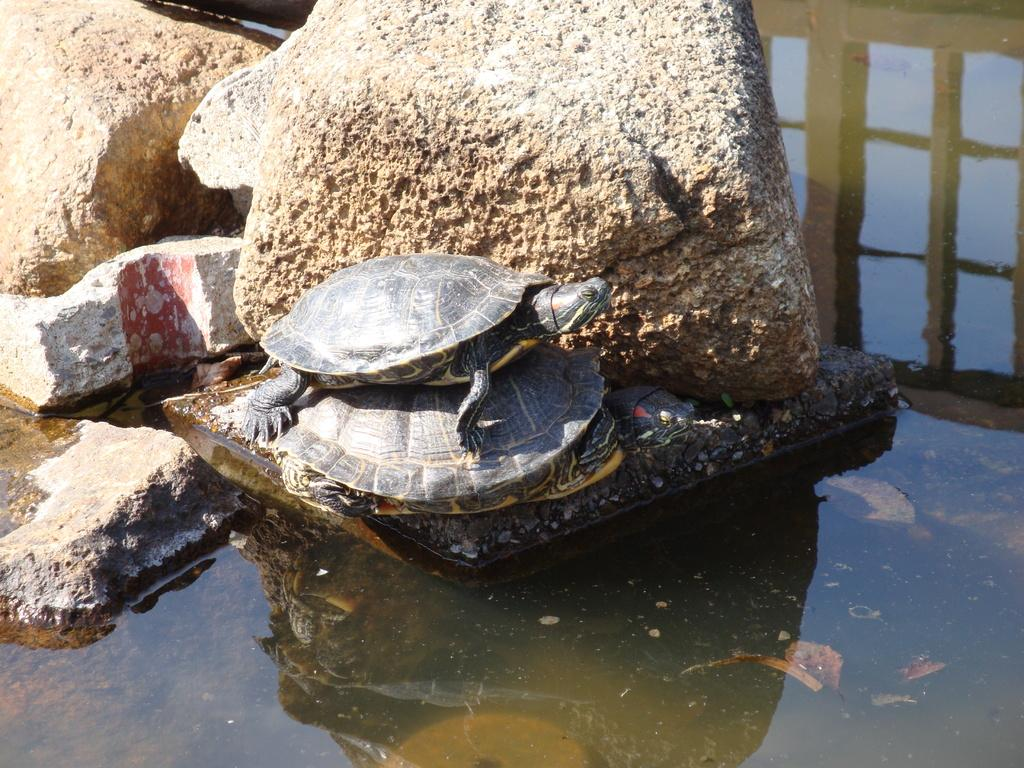What animals are in the center of the image? There are turtles in the center of the image. What is at the bottom of the image? There is water at the bottom of the image. What can be seen in the background of the image? There are rocks in the background of the image. What decision did the turtles make in the image? There is no indication in the image that the turtles made any decisions, as they are simply depicted in their environment. 